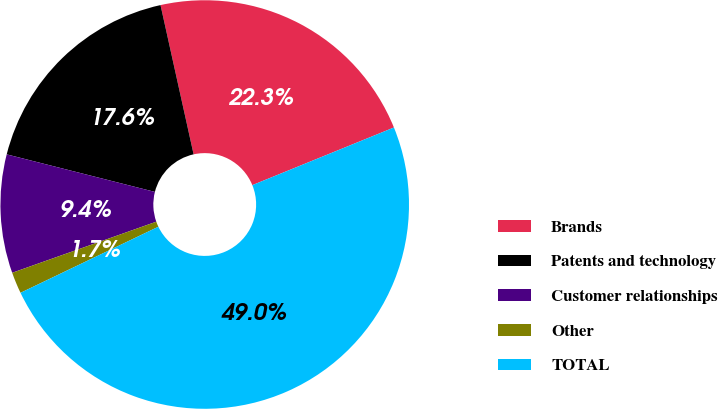<chart> <loc_0><loc_0><loc_500><loc_500><pie_chart><fcel>Brands<fcel>Patents and technology<fcel>Customer relationships<fcel>Other<fcel>TOTAL<nl><fcel>22.32%<fcel>17.58%<fcel>9.37%<fcel>1.69%<fcel>49.04%<nl></chart> 